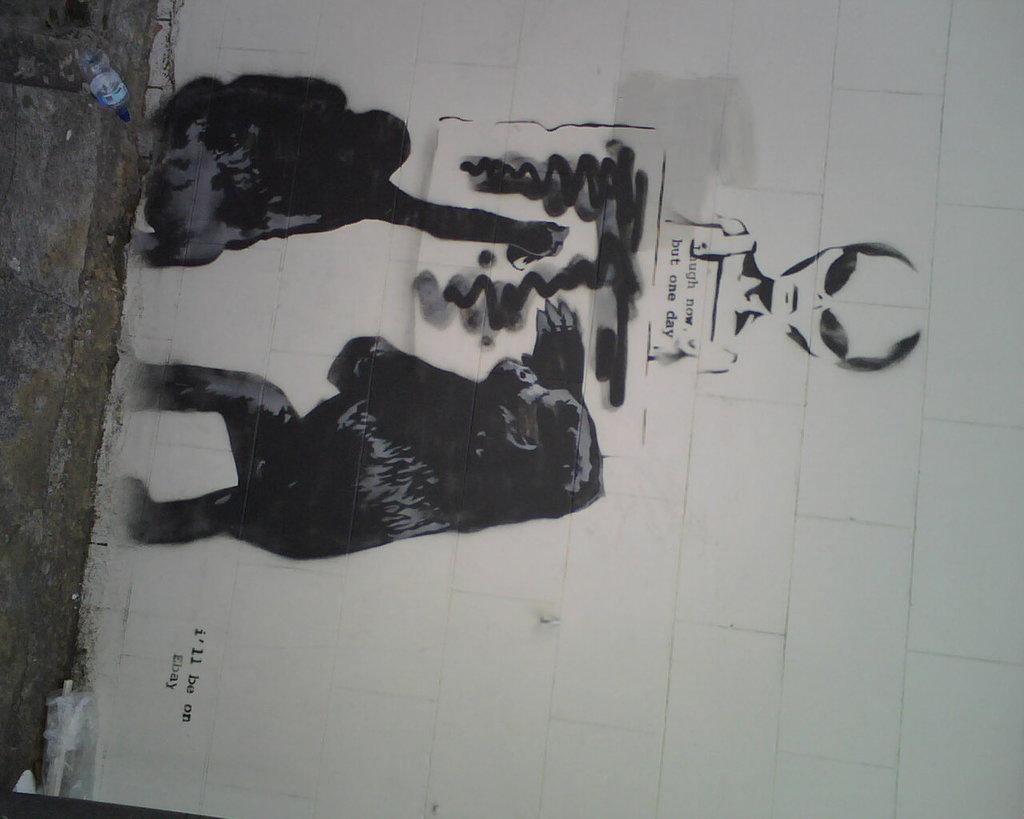What is the main subject of the image? There is a hoarding in the image. What is depicted on the hoarding? The hoarding features two chimpanzees. What are the chimpanzees doing in the image? The chimpanzees are painting on a board. What else can be seen in the image besides the hoarding? There is a person painting on a white wall. What is the location of the white wall in the image? The white wall is near grass on the ground. What type of whip is being used by the chimpanzees to create peace in the image? There is no whip or reference to peace in the image; the chimpanzees are simply painting on a board. 